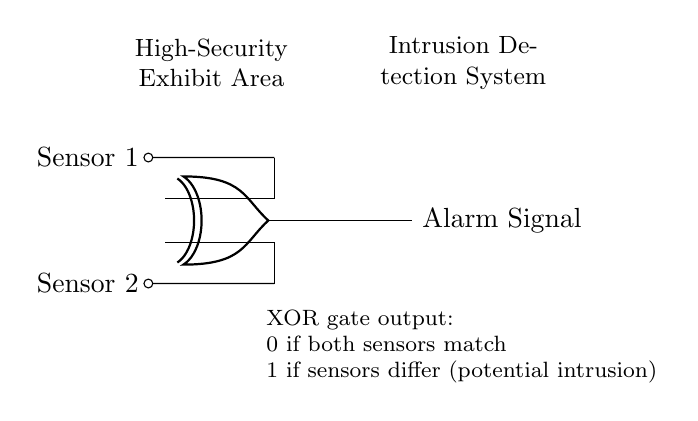What type of gate is used in this system? The circuit diagram displays an XOR gate, identified by the specific shape and label of the gate. XOR gates are characterized by their unique output based on the inputs.
Answer: XOR gate How many sensors are shown in the diagram? The diagram includes two sensors, indicated by the labels "Sensor 1" and "Sensor 2," both connected to the XOR gate.
Answer: Two sensors What is the output signal when both sensors are activated? According to the explanatory text within the diagram, if both sensors signal the same condition (both activated), the output of the XOR gate will be 0.
Answer: Zero What condition causes an alarm to trigger in this circuit? The alarm signal is triggered when the inputs from the two sensors differ, as explained in the diagram's output rule for the XOR gate. This means if one sensor is activated and the other is not, the output is 1 (alarm).
Answer: Differing inputs If both sensors are inactive, what is the output of the XOR gate? When both sensors are inactive, the XOR gate also produces a 0 output. This is because the gate only outputs a 1 when there is a discrepancy between the two inputs.
Answer: Zero What role does the XOR gate play in the intrusion detection system? The XOR gate functions to compare the statuses of the two sensors. Its unique property provides an output indicating potential intrusions when the sensors indicate different statuses, helping identify unauthorized access.
Answer: Comparison of sensor statuses When does the output become one? The output becomes one when the states of the two sensors differ; this could occur when one sensor is triggered while the other remains idle. This scenario is the basis for detecting possible intrusions.
Answer: When states differ 